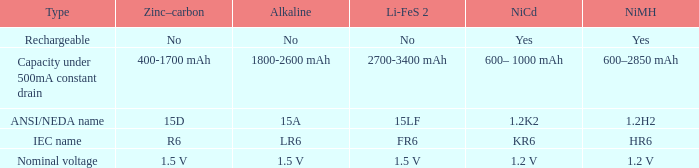What is Li-FeS 2, when Type is Nominal Voltage? 1.5 V. 